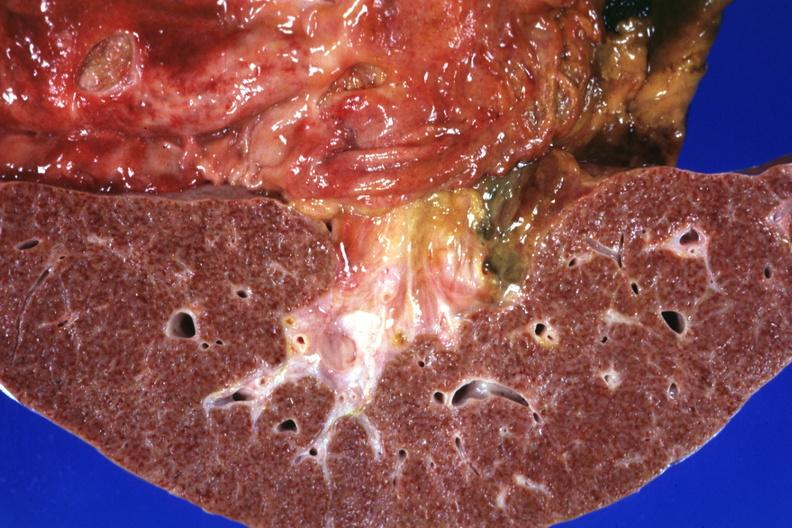s large cell lymphoma present?
Answer the question using a single word or phrase. No 